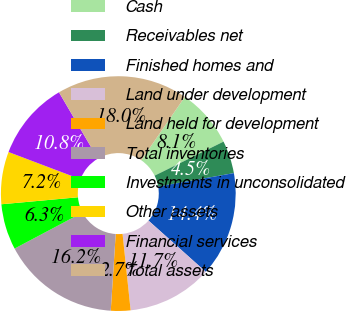<chart> <loc_0><loc_0><loc_500><loc_500><pie_chart><fcel>Cash<fcel>Receivables net<fcel>Finished homes and<fcel>Land under development<fcel>Land held for development<fcel>Total inventories<fcel>Investments in unconsolidated<fcel>Other assets<fcel>Financial services<fcel>Total assets<nl><fcel>8.11%<fcel>4.51%<fcel>14.41%<fcel>11.71%<fcel>2.7%<fcel>16.22%<fcel>6.31%<fcel>7.21%<fcel>10.81%<fcel>18.02%<nl></chart> 